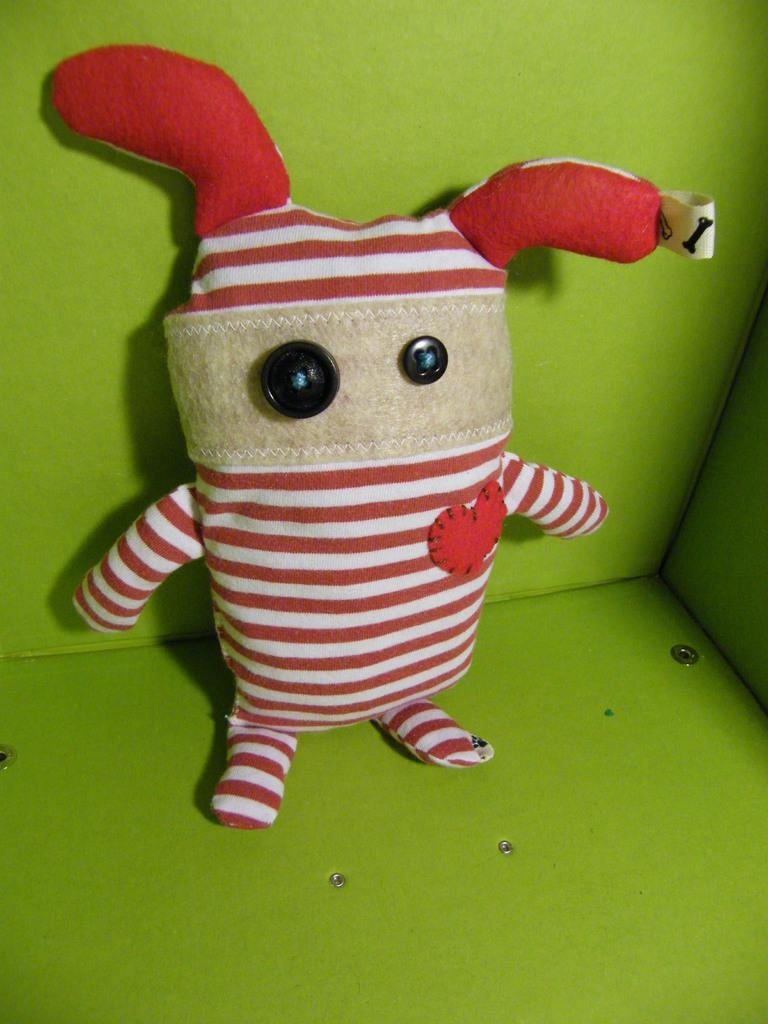What type of toy is present in the image? There is a toy with buttons in the image. What color is the wall in the background of the image? The wall in the background of the image is green. What type of trade is happening between the deer in the image? There are no deer present in the image; it features a toy with buttons and a green wall in the background. 